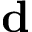Convert formula to latex. <formula><loc_0><loc_0><loc_500><loc_500>d</formula> 